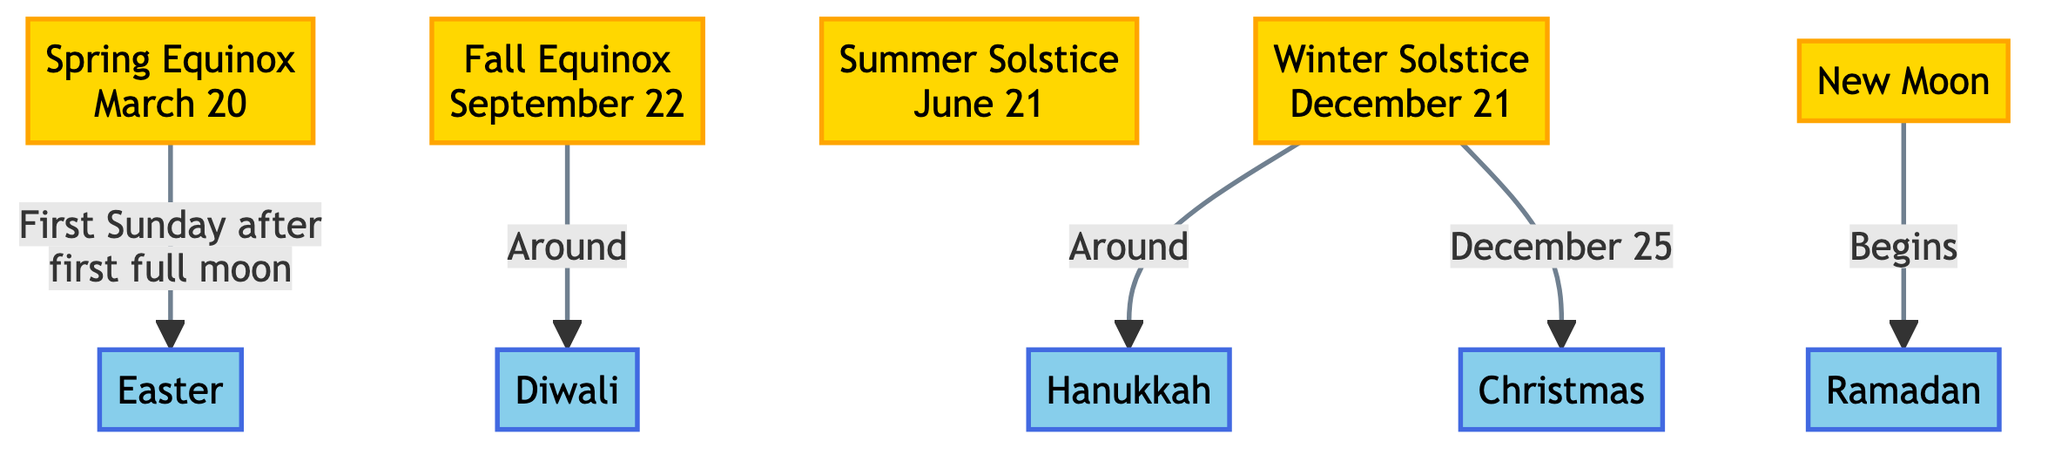What's the date of the Spring Equinox? The diagram clearly states that the Spring Equinox occurs on March 20.
Answer: March 20 How is Easter determined according to the diagram? The diagram shows that Easter is determined by the first Sunday after the first full moon following the Spring Equinox.
Answer: First Sunday after first full moon Which religious festival is associated with the Winter Solstice? The diagram indicates that Hanukkah occurs around the Winter Solstice, establishing a connection between the two.
Answer: Hanukkah How many celestial events are listed in the diagram? By counting the nodes in the celestial category, there are four celestial events: Spring Equinox, Fall Equinox, Summer Solstice, and Winter Solstice.
Answer: 4 What religious festival begins with the New Moon? The diagram directly connects the New Moon with the beginning of Ramadan, indicating that Ramadan starts at this celestial occurrence.
Answer: Ramadan Which two festivals are situated around the Fall Equinox? The diagram shows that both Diwali and the Fall Equinox are linked, with Diwali occurring around the Fall Equinox, providing the answer.
Answer: Diwali What date is Christmas linked to in the diagram? The diagram notes that Christmas is linked to December 25, which is explicitly mentioned in relation to the Winter Solstice.
Answer: December 25 How many religious festivals are shown in the diagram? The diagram lists five religious festivals: Easter, Ramadan, Hanukkah, Diwali, and Christmas, which totals to five festivals.
Answer: 5 